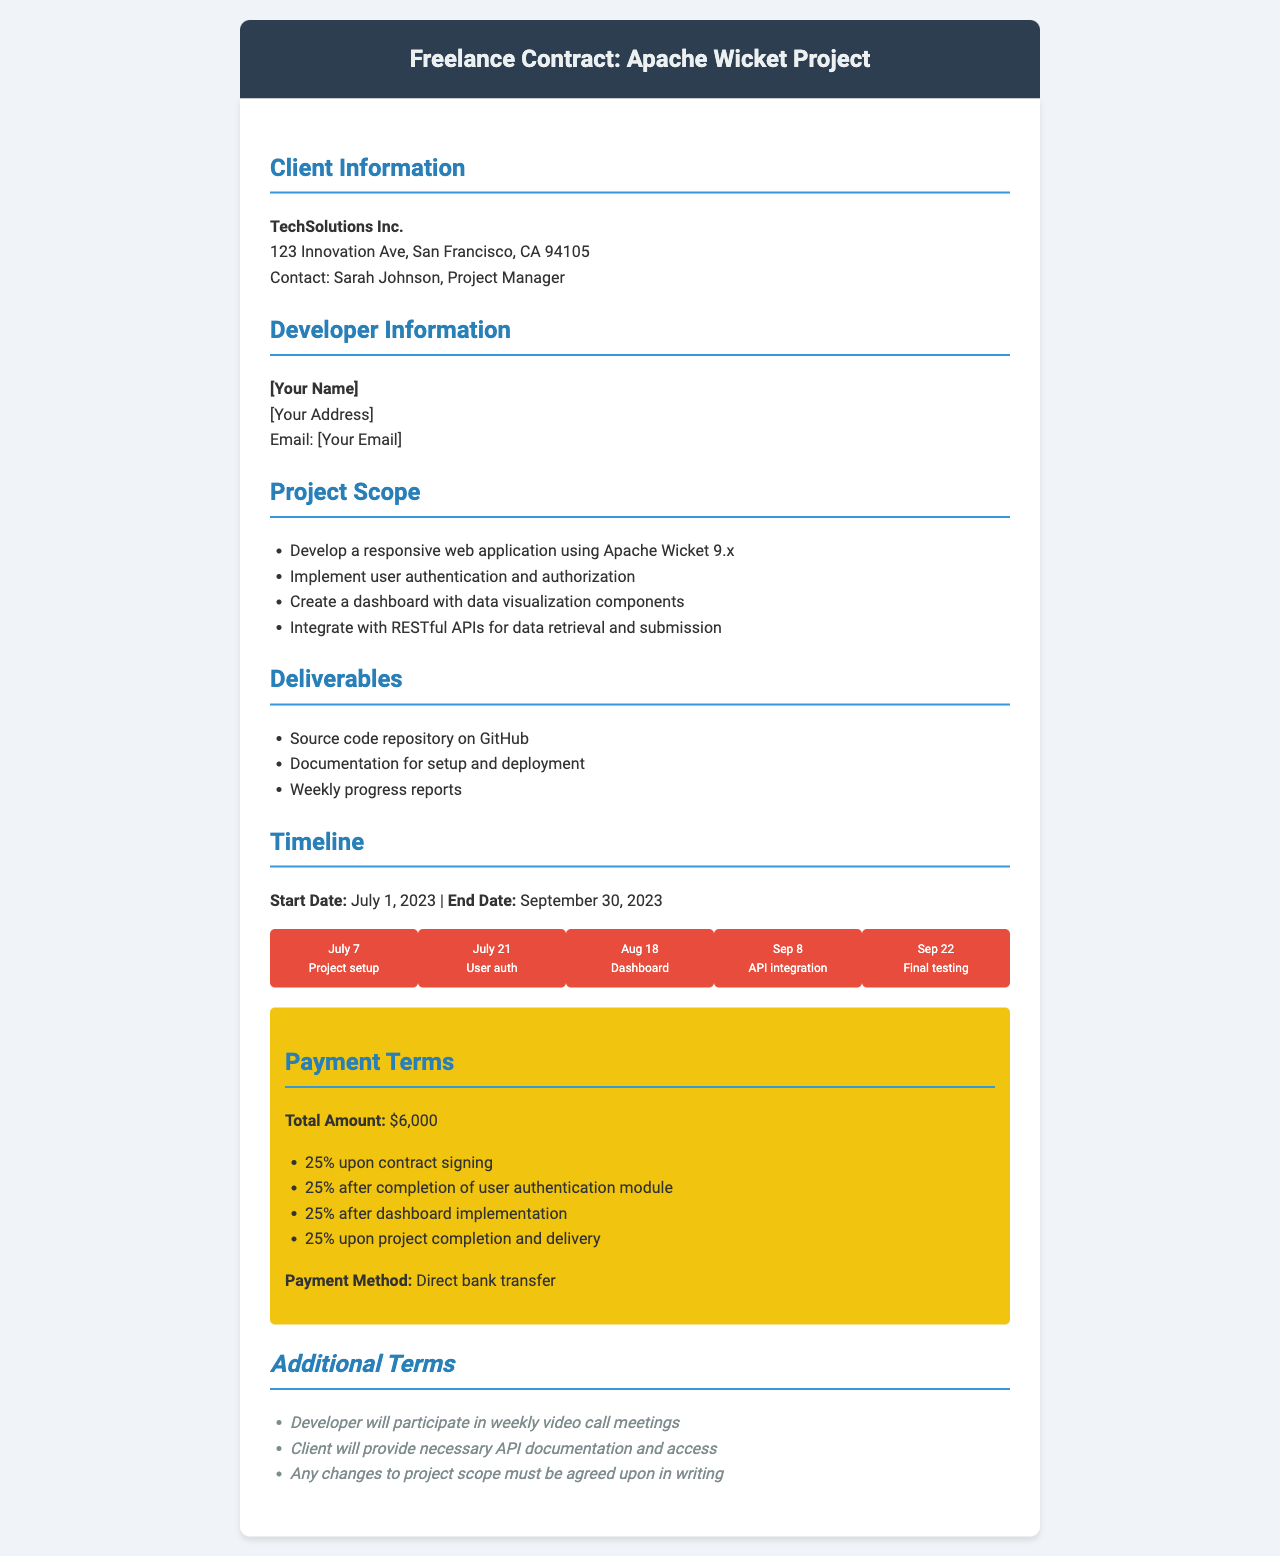what is the client's name? The client's name is mentioned in the document under Client Information, which is TechSolutions Inc.
Answer: TechSolutions Inc what is the total contract amount? The total contract amount is stated in the Payment Terms section of the document.
Answer: $6,000 when does the project start? The project start date is outlined in the Timeline section of the document.
Answer: July 1, 2023 how much is paid after user authentication completion? This payment term is found in the Payment Terms section where milestone payments are listed.
Answer: 25% what deliverable is required on GitHub? The deliverable about GitHub is mentioned in the Deliverables section of the document.
Answer: Source code repository on GitHub which method of payment is specified? The payment method can be found in the Payment Terms section of the document.
Answer: Direct bank transfer what is the deadline for final testing? The timeline for final testing is indicated in the Timeline section of the document.
Answer: September 22 who will the developer have weekly meetings with? The weekly meetings are outlined in the Additional Terms section with reference to the client.
Answer: Client what is the purpose of the Apache Wicket project? The purpose of the project is evident in the Project Scope section that describes the application being developed.
Answer: Responsive web application using Apache Wicket 9.x 